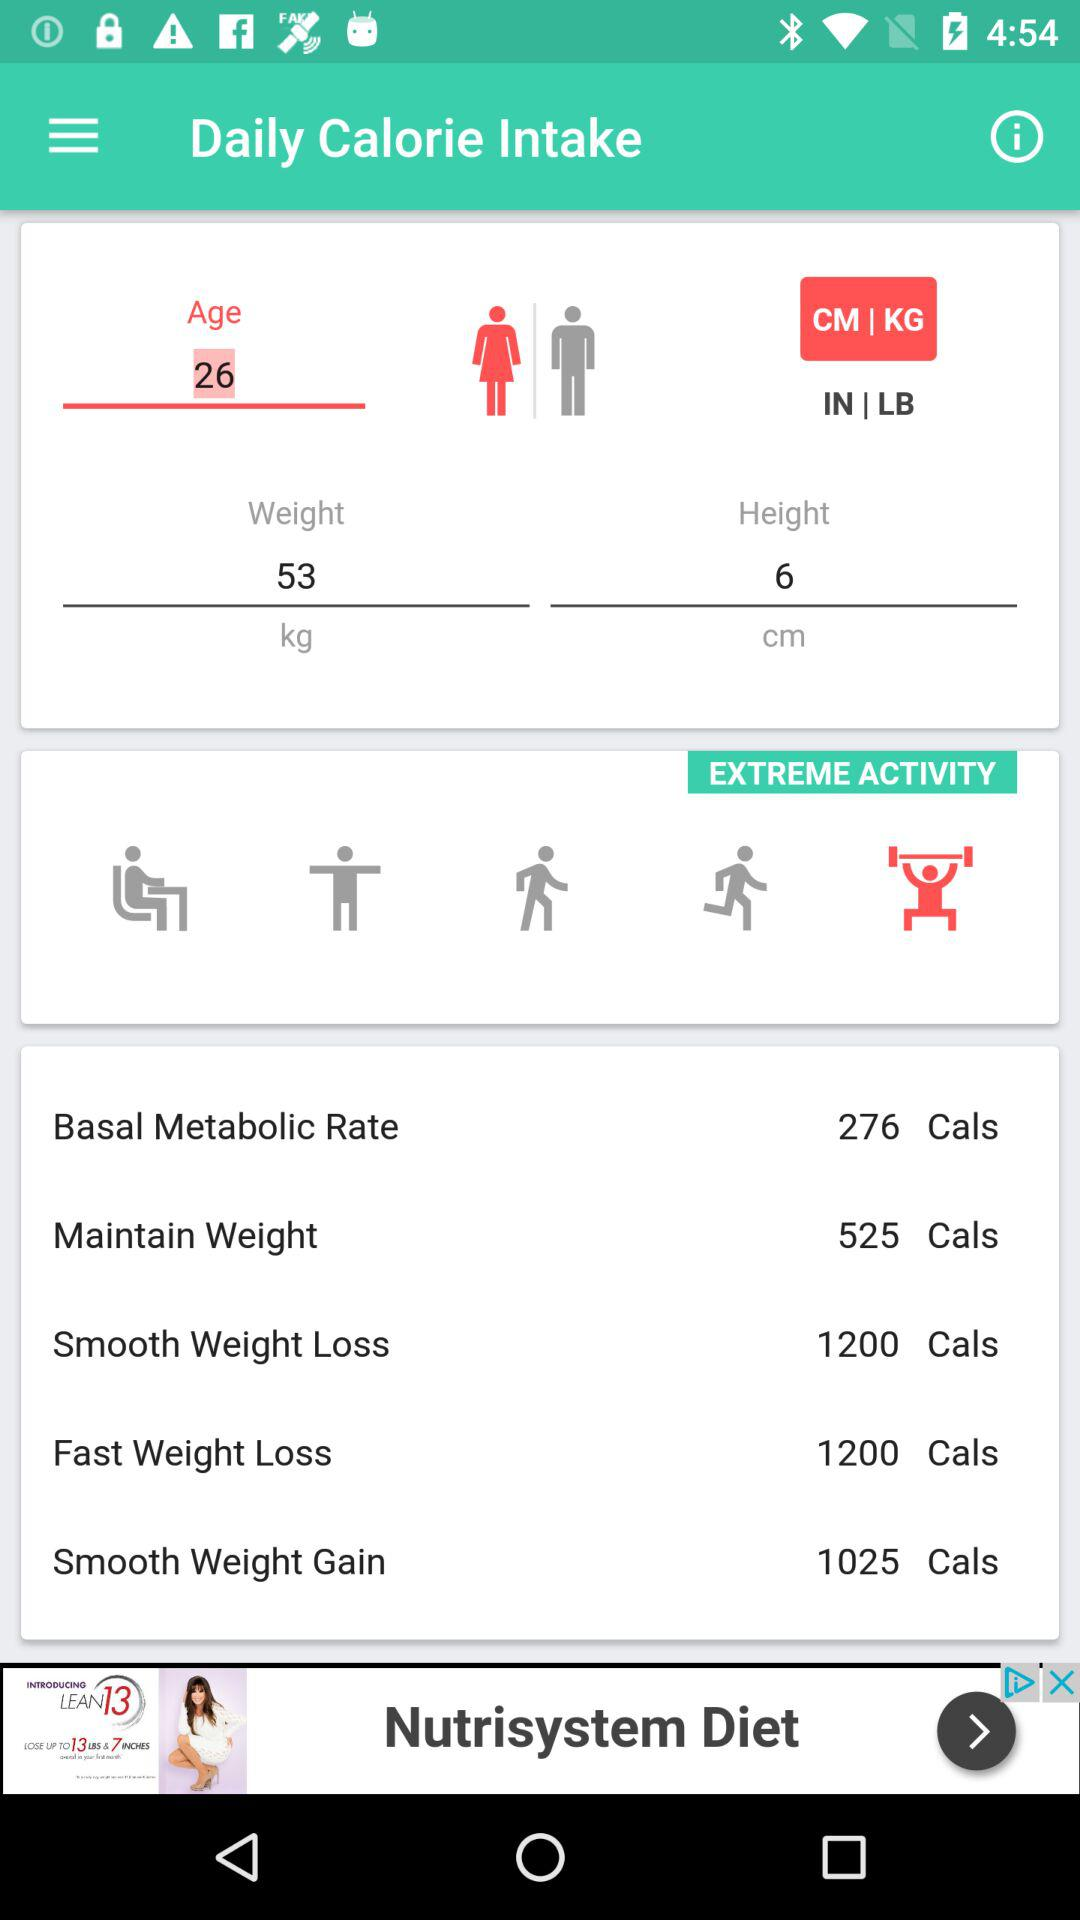What is the age? The age is 26 years. 